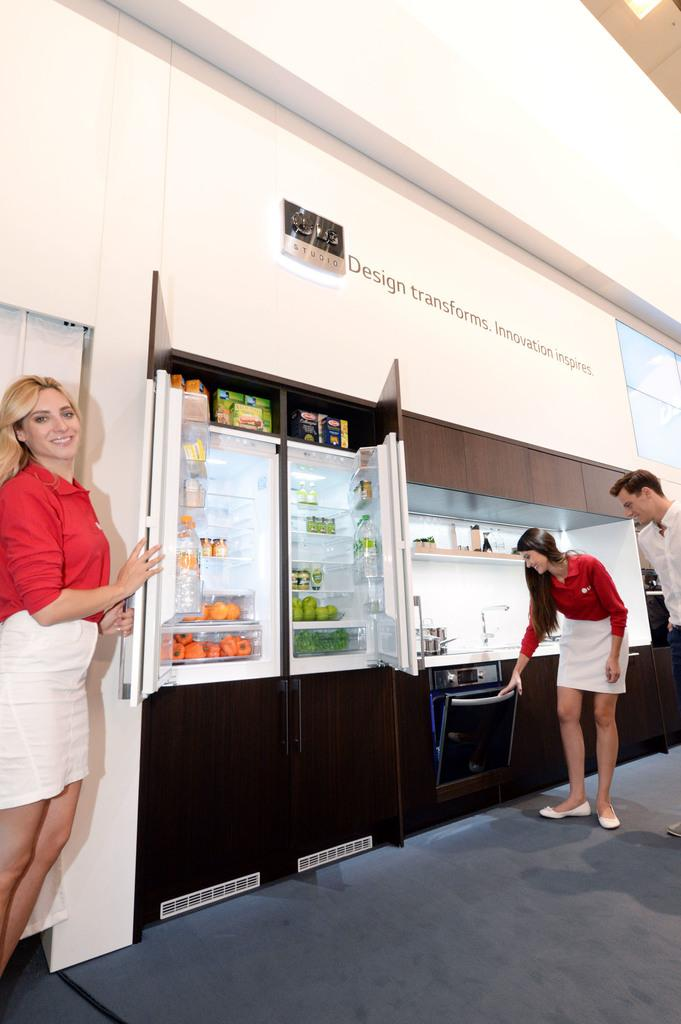<image>
Provide a brief description of the given image. Several people look at kitchen appliances under a banner that reads "Design transforms. Innovation Inspires." 